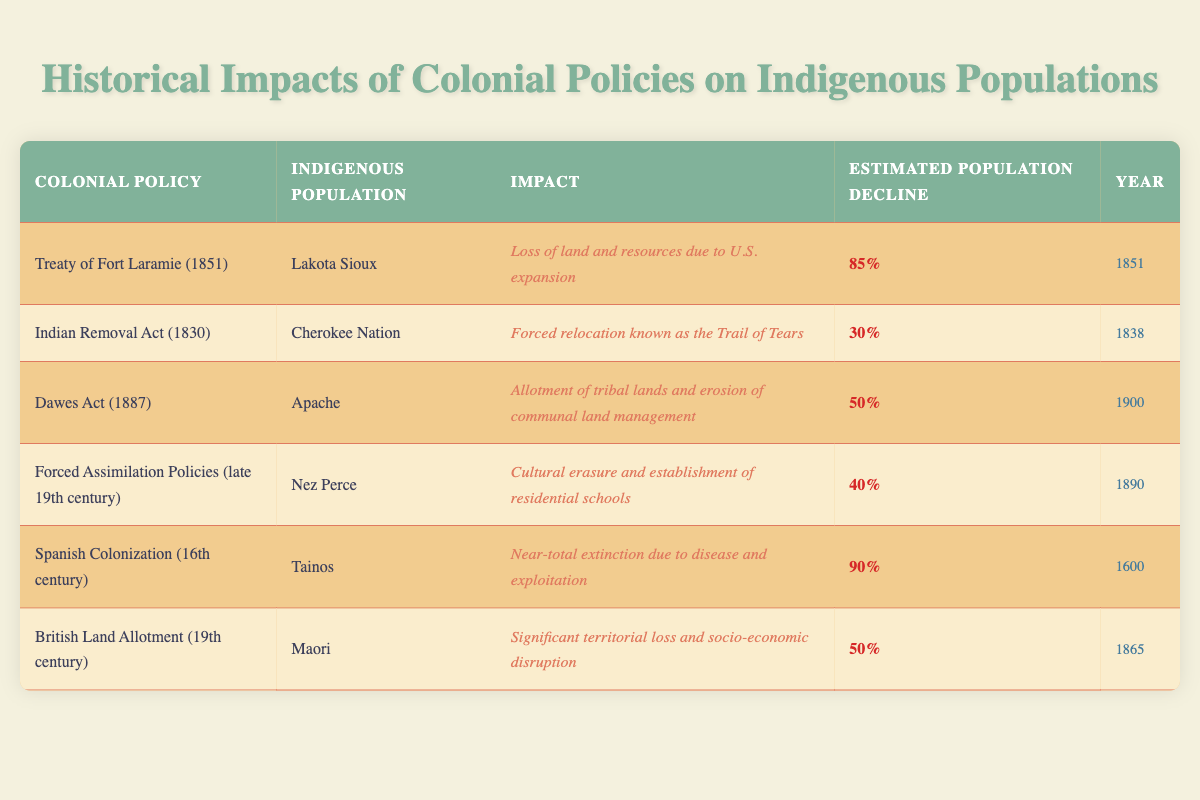What was the estimated population decline of the Lakota Sioux due to the Treaty of Fort Laramie in 1851? The table indicates that the estimated population decline of the Lakota Sioux as a result of the Treaty of Fort Laramie (1851) was 85%.
Answer: 85% What impact did the Indian Removal Act have on the Cherokee Nation? According to the table, the Indian Removal Act resulted in the forced relocation of the Cherokee Nation, commonly known as the Trail of Tears.
Answer: Forced relocation known as the Trail of Tears How many indigenous populations were affected by policies with a population decline of 50% or more? The table lists three indigenous populations that experienced a decline of 50% or more: Lakota Sioux (85%), Tainos (90%), and Cherokee Nation (30%). However, only the Lakota Sioux and Tainos meet the criteria of 50% or more, therefore, the affected populations are 3.
Answer: 3 Is it true that the Dawes Act resulted in a population decline for the Apache tribe? The table confirms that the Dawes Act led to a 50% population decline in the Apache tribe. Therefore, the statement is true.
Answer: Yes What was the population decline percentage for both the Nez Perce and the Maori? Looking at the table, the Nez Perce experienced a 40% decline while the Maori faced a 50% decline. Therefore, we can summarize these figures as both groups experienced significant losses.
Answer: Nez Perce: 40%, Maori: 50% Was the impact of Spanish Colonization more severe than that of the Dawes Act? The table shows that Spanish Colonization had a near-total extinction impact on the Tainos, with a 90% population decline, while the Dawes Act resulted in a 50% decline for the Apache. This indicates that Spanish Colonization had a more severe effect.
Answer: Yes What is the average estimated population decline among the populations listed in the table? To calculate the average, first convert the percentage declines to numerical values: 85%, 30%, 50%, 40%, 90%, and 50%. Adding these yields a total of 345%. Then, divide by the number of populations, which is 6. So, 345% divided by 6 is 57.5%.
Answer: 57.5% Which colonial policy resulted in the highest estimated population decline? The table indicates that Spanish Colonization resulted in the highest estimated population decline of 90% for the Tainos.
Answer: Spanish Colonization How many policies were enacted in the 19th century compared to the 16th century? The table shows that there are five policies in the 19th century (Treaty of Fort Laramie, Indian Removal Act, Dawes Act, Forced Assimilation Policies, and British Land Allotment) and one policy from the 16th century (Spanish Colonization). Therefore, the comparison reveals that five 19th-century policies were enacted compared to one from the 16th century.
Answer: 5 vs 1 